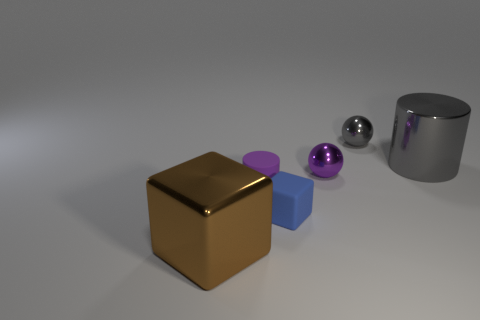Add 1 blue rubber cubes. How many objects exist? 7 Subtract 1 spheres. How many spheres are left? 1 Subtract all gray cylinders. How many cylinders are left? 1 Subtract all cubes. How many objects are left? 4 Add 3 blue blocks. How many blue blocks exist? 4 Subtract 0 brown spheres. How many objects are left? 6 Subtract all gray spheres. Subtract all gray blocks. How many spheres are left? 1 Subtract all red things. Subtract all metal balls. How many objects are left? 4 Add 2 purple spheres. How many purple spheres are left? 3 